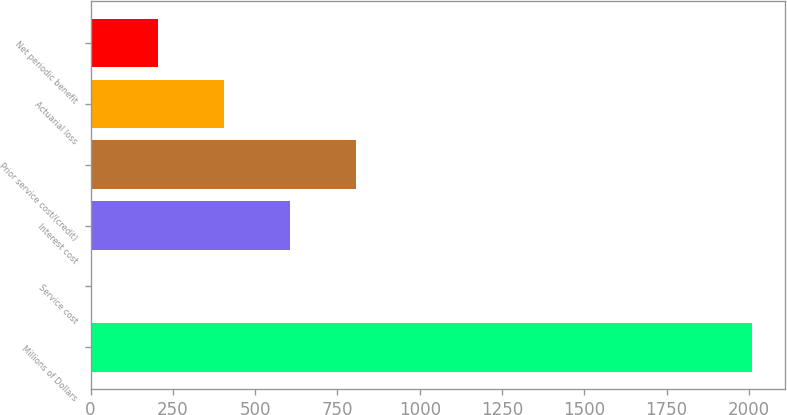Convert chart to OTSL. <chart><loc_0><loc_0><loc_500><loc_500><bar_chart><fcel>Millions of Dollars<fcel>Service cost<fcel>Interest cost<fcel>Prior service cost/(credit)<fcel>Actuarial loss<fcel>Net periodic benefit<nl><fcel>2008<fcel>3<fcel>604.5<fcel>805<fcel>404<fcel>203.5<nl></chart> 